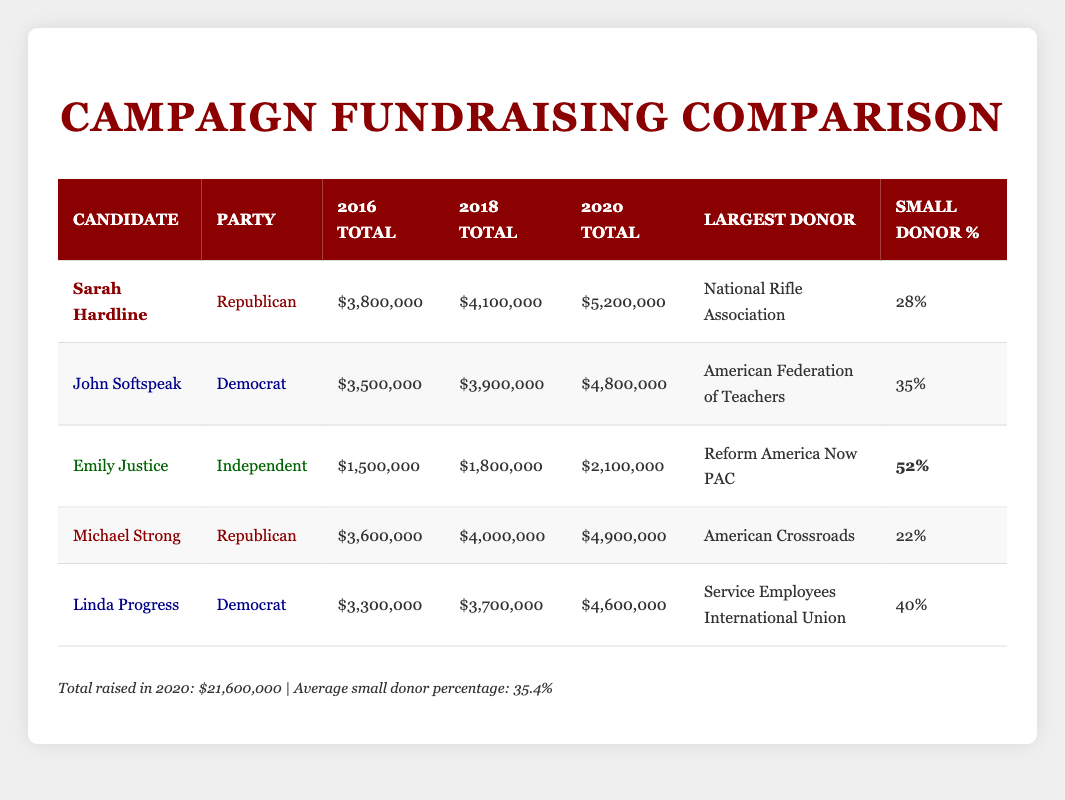What were Sarah Hardline's fundraising totals in 2020? According to the table, Sarah Hardline raised $5,200,000 in 2020.
Answer: $5,200,000 Which candidate documented the highest percentage of small donors? The table shows that Emily Justice had the highest small donor percentage at 52%.
Answer: 52% What is the total amount raised by Linda Progress across all three election years? Adding the totals for Linda Progress gives $3,300,000 (2016) + $3,700,000 (2018) + $4,600,000 (2020) = $11,600,000.
Answer: $11,600,000 Did Michael Strong raise more money than John Softspeak in 2018? In 2018, Michael Strong raised $4,000,000 while John Softspeak raised $3,900,000. Thus, Michael Strong raised more.
Answer: Yes What is the difference in total fundraising between Sarah Hardline and Michael Strong for the year 2020? Sarah Hardline raised $5,200,000 while Michael Strong raised $4,900,000 in 2020. The difference is $5,200,000 - $4,900,000 = $300,000.
Answer: $300,000 Which party's candidates, on average, raised more money in 2020? In 2020, the Republican candidates Sarah Hardline and Michael Strong collectively raised $10,100,000, while the Democratic candidates John Softspeak and Linda Progress raised a total of $9,400,000. Thus, Republicans raised more.
Answer: Republican What percentage of small donors did John Softspeak have compared to the average percentage of small donors across all candidates? John Softspeak's small donor percentage is 35%, while the average percentage of small donors across all candidates is 35.4%. Therefore, John Softspeak's percentage is slightly below the average.
Answer: No Calculate the total amount raised by all candidates combined in 2016. The totals for each candidate in 2016 are: Sarah Hardline ($3,800,000) + John Softspeak ($3,500,000) + Emily Justice ($1,500,000) + Michael Strong ($3,600,000) + Linda Progress ($3,300,000) = $15,700,000.
Answer: $15,700,000 What candidate had the smallest total fundraising in 2020? From the table, Emily Justice raised the least in 2020 with $2,100,000.
Answer: $2,100,000 